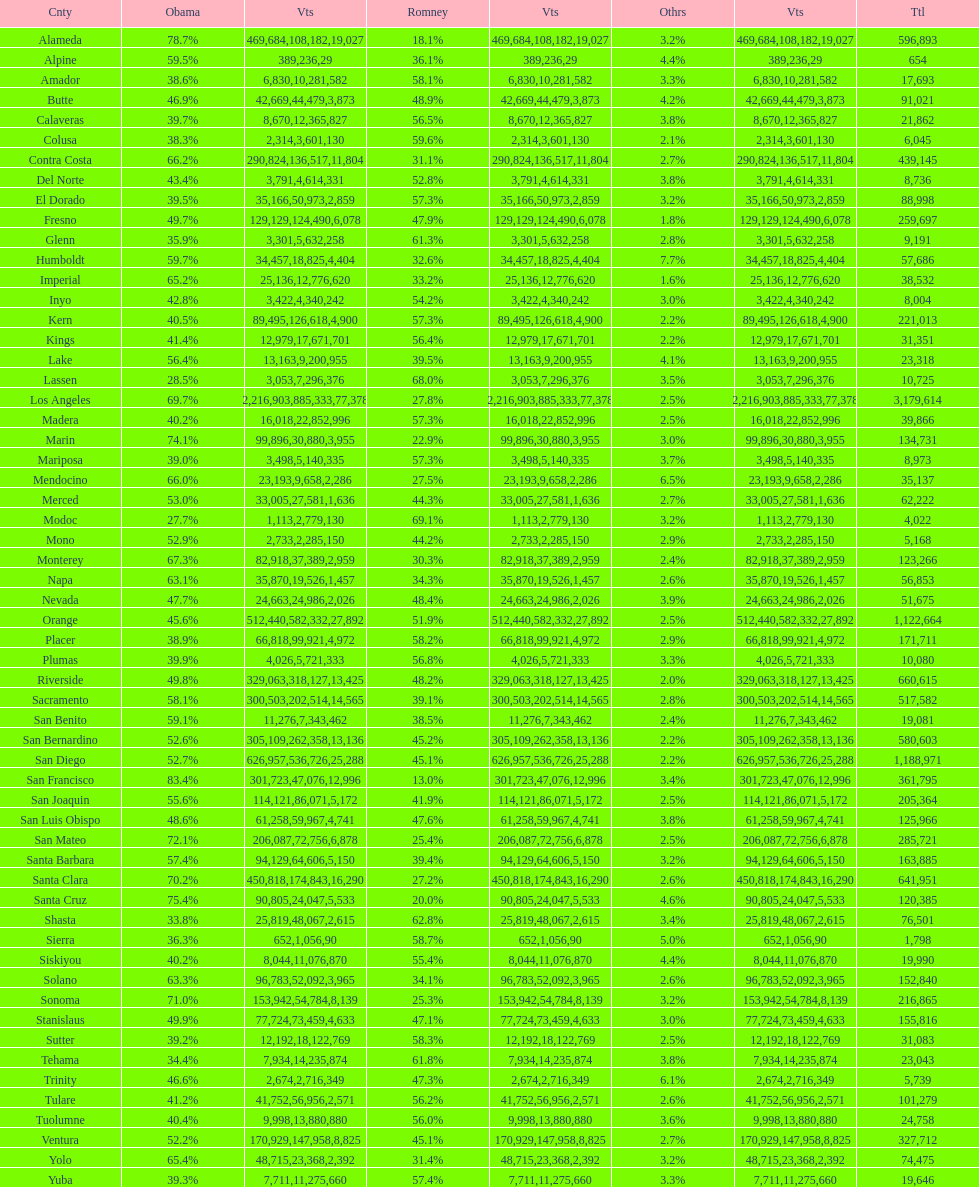What is the number of votes for obama for del norte and el dorado counties? 38957. 